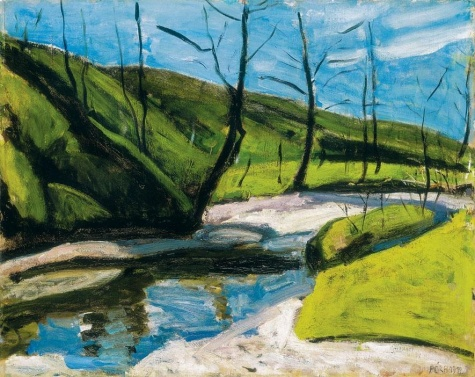What emotions does this painting evoke, and how does the artist achieve this? The painting evokes feelings of peace and serenity, reinforced by the harmonious palette of soft greens and blues. The gentle flow of the river and the open sky contribute to a sense of limitless possibility and calm. The artist enhances these emotions through the rhythmic placement of trees and the naturalistic bend of the river, guiding the viewer's eye smoothly through the canvas, which allows for a tranquil exploration of the scene. 